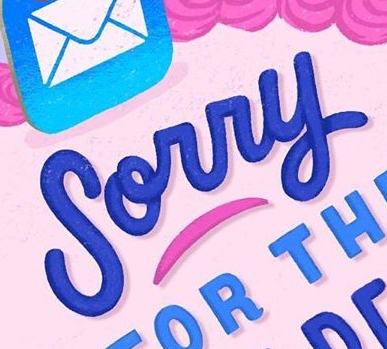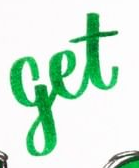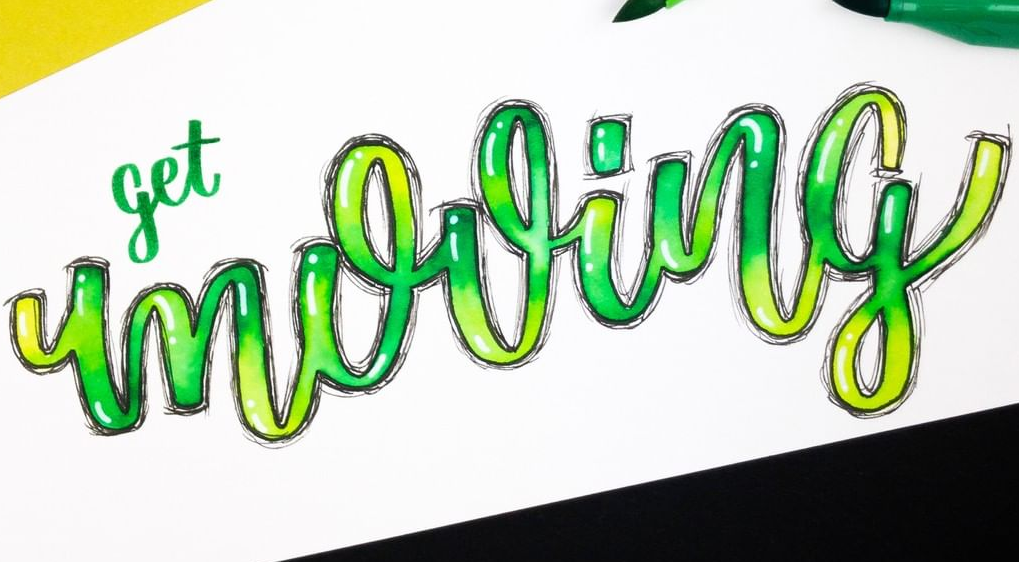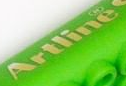Read the text from these images in sequence, separated by a semicolon. Sorry; get; mooing; Artline 